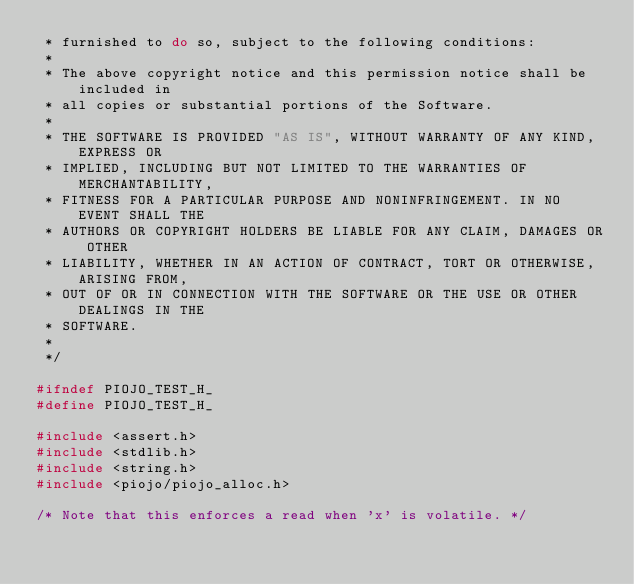<code> <loc_0><loc_0><loc_500><loc_500><_C_> * furnished to do so, subject to the following conditions:
 *
 * The above copyright notice and this permission notice shall be included in
 * all copies or substantial portions of the Software.
 *
 * THE SOFTWARE IS PROVIDED "AS IS", WITHOUT WARRANTY OF ANY KIND, EXPRESS OR
 * IMPLIED, INCLUDING BUT NOT LIMITED TO THE WARRANTIES OF MERCHANTABILITY,
 * FITNESS FOR A PARTICULAR PURPOSE AND NONINFRINGEMENT. IN NO EVENT SHALL THE
 * AUTHORS OR COPYRIGHT HOLDERS BE LIABLE FOR ANY CLAIM, DAMAGES OR OTHER
 * LIABILITY, WHETHER IN AN ACTION OF CONTRACT, TORT OR OTHERWISE, ARISING FROM,
 * OUT OF OR IN CONNECTION WITH THE SOFTWARE OR THE USE OR OTHER DEALINGS IN THE
 * SOFTWARE.
 *
 */

#ifndef PIOJO_TEST_H_
#define PIOJO_TEST_H_

#include <assert.h>
#include <stdlib.h>
#include <string.h>
#include <piojo/piojo_alloc.h>

/* Note that this enforces a read when 'x' is volatile. */</code> 